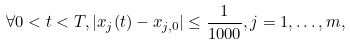<formula> <loc_0><loc_0><loc_500><loc_500>\forall 0 < t < T , | x _ { j } ( t ) - x _ { j , 0 } | \leq \frac { 1 } { 1 0 0 0 } , j = 1 , \dots , m ,</formula> 